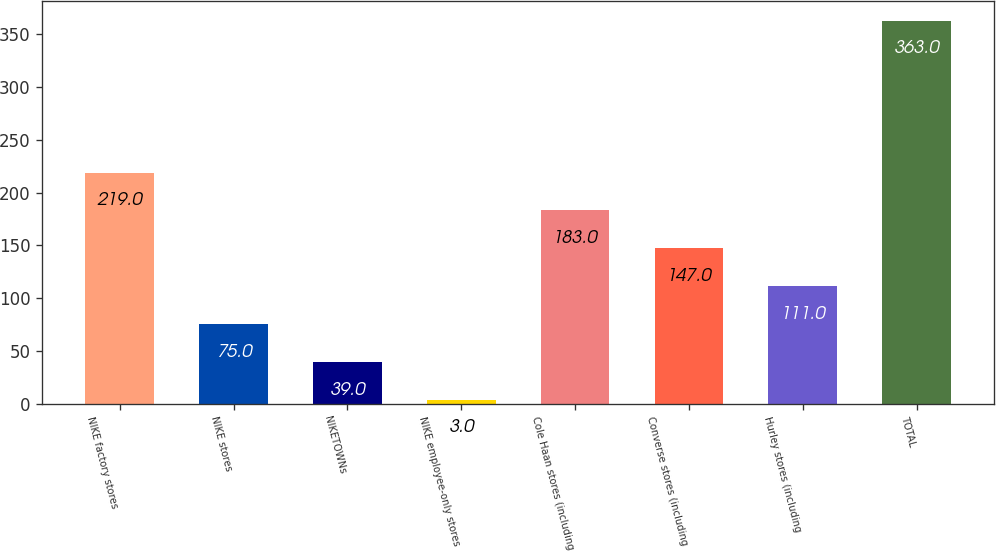Convert chart. <chart><loc_0><loc_0><loc_500><loc_500><bar_chart><fcel>NIKE factory stores<fcel>NIKE stores<fcel>NIKETOWNs<fcel>NIKE employee-only stores<fcel>Cole Haan stores (including<fcel>Converse stores (including<fcel>Hurley stores (including<fcel>TOTAL<nl><fcel>219<fcel>75<fcel>39<fcel>3<fcel>183<fcel>147<fcel>111<fcel>363<nl></chart> 